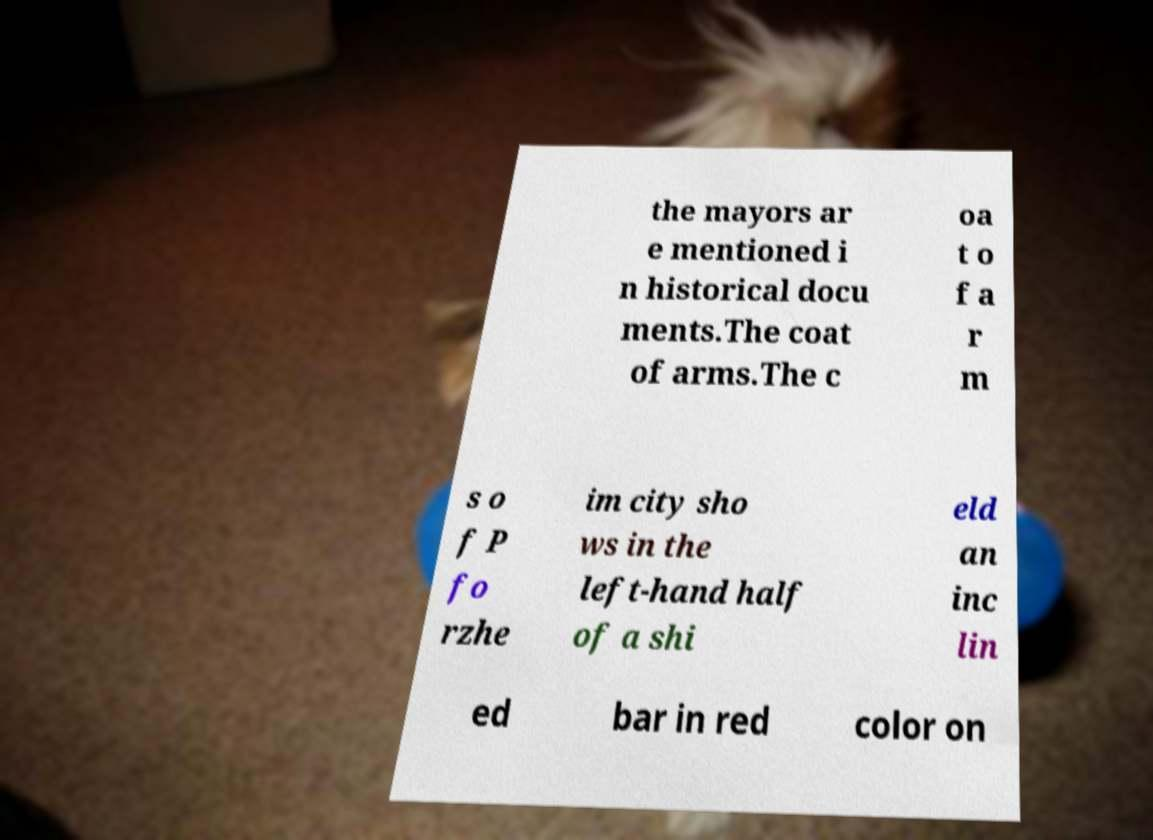I need the written content from this picture converted into text. Can you do that? the mayors ar e mentioned i n historical docu ments.The coat of arms.The c oa t o f a r m s o f P fo rzhe im city sho ws in the left-hand half of a shi eld an inc lin ed bar in red color on 